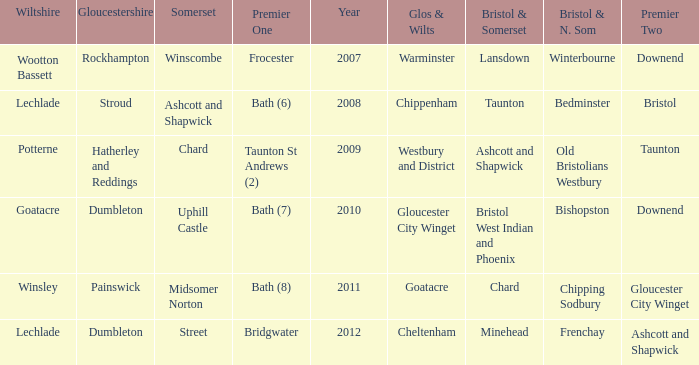What is the latest year where glos & wilts is warminster? 2007.0. 